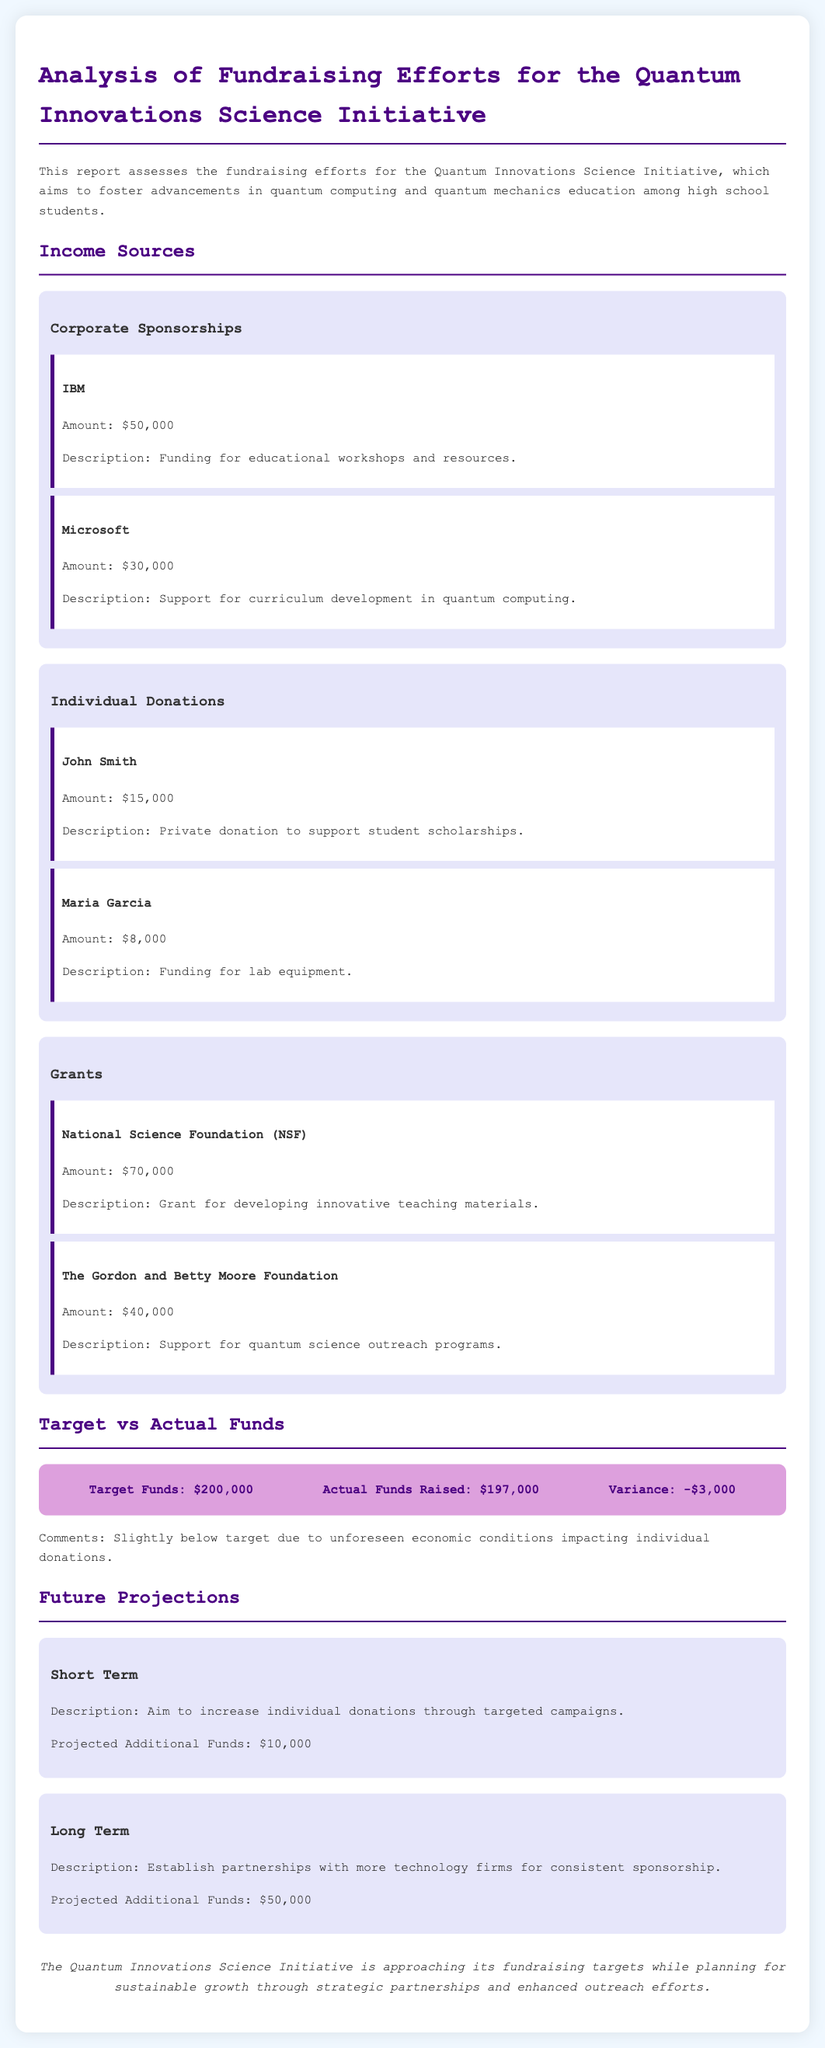What is the total amount raised from corporate sponsorships? The total amount raised from corporate sponsorships is the sum of IBM and Microsoft donations, which is $50,000 + $30,000.
Answer: $80,000 Who provided a private donation of $15,000? John Smith is the individual who made a private donation of $15,000.
Answer: John Smith What is the variance between target and actual funds raised? The variance is calculated by subtracting actual funds raised from target funds, which is $200,000 - $197,000.
Answer: -$3,000 What is the projected amount from short term strategies? The projected additional funds from short term strategies is explicitly stated in the document.
Answer: $10,000 Which foundation provided $70,000 for the initiative? The National Science Foundation (NSF) is the entity that provided $70,000.
Answer: National Science Foundation (NSF) What is the target funds amount? The target funds amount is mentioned directly in the report, which is $200,000.
Answer: $200,000 What type of organization is Quantum Innovations Science Initiative striving to establish partnerships with? The initiative is looking to establish partnerships with technology firms for funding.
Answer: Technology firms What amount did The Gordon and Betty Moore Foundation contribute? The contribution from The Gordon and Betty Moore Foundation is explicitly provided in the report.
Answer: $40,000 What is the overall conclusion about the fundraising efforts? The conclusion summarizes the current status and future aspirations of the initiative.
Answer: Approaching its fundraising targets while planning for sustainable growth 